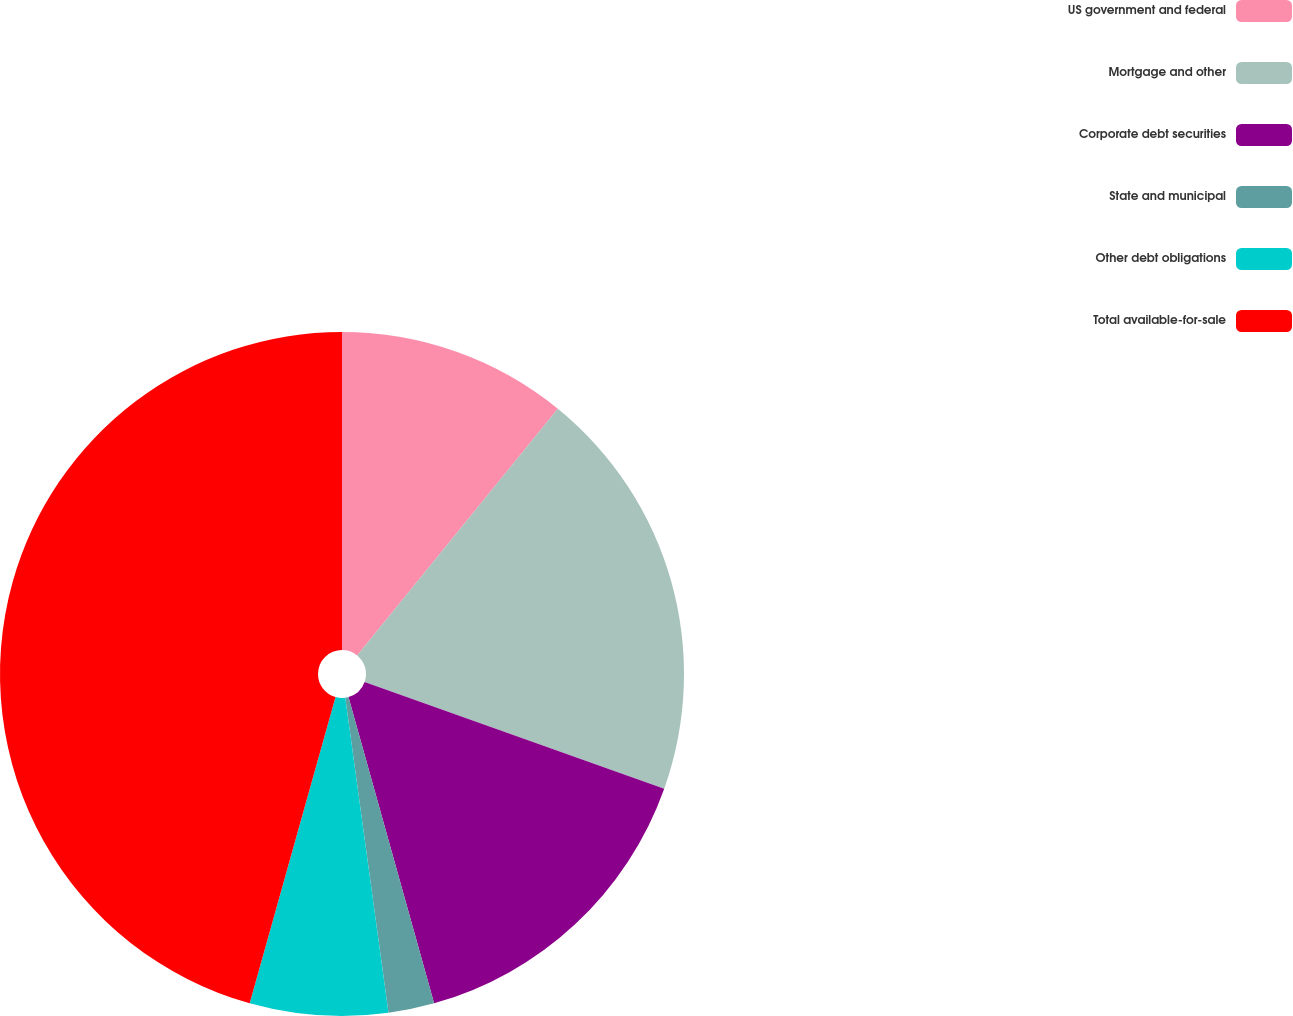Convert chart to OTSL. <chart><loc_0><loc_0><loc_500><loc_500><pie_chart><fcel>US government and federal<fcel>Mortgage and other<fcel>Corporate debt securities<fcel>State and municipal<fcel>Other debt obligations<fcel>Total available-for-sale<nl><fcel>10.87%<fcel>19.57%<fcel>15.22%<fcel>2.17%<fcel>6.52%<fcel>45.65%<nl></chart> 